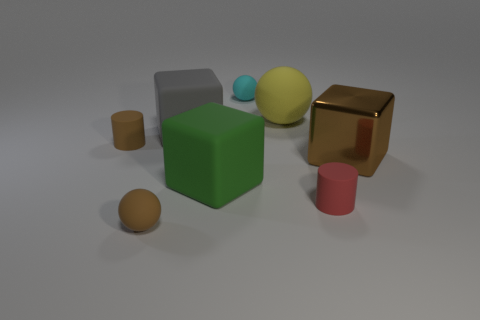Subtract all brown balls. How many balls are left? 2 Add 1 balls. How many objects exist? 9 Subtract all red cylinders. How many cylinders are left? 1 Subtract all cubes. How many objects are left? 5 Subtract 2 blocks. How many blocks are left? 1 Subtract all cyan blocks. Subtract all cyan cylinders. How many blocks are left? 3 Subtract all yellow balls. How many purple cylinders are left? 0 Subtract all big gray matte blocks. Subtract all yellow objects. How many objects are left? 6 Add 4 tiny matte cylinders. How many tiny matte cylinders are left? 6 Add 4 tiny cyan matte spheres. How many tiny cyan matte spheres exist? 5 